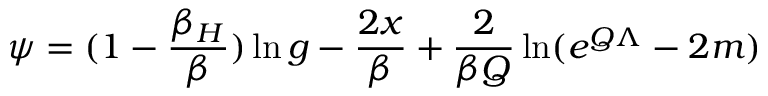Convert formula to latex. <formula><loc_0><loc_0><loc_500><loc_500>\psi = ( 1 - { \frac { \beta _ { H } } { \beta } } ) \ln g - { \frac { 2 x } { \beta } } + { \frac { 2 } { \beta Q } } \ln ( e ^ { Q \Lambda } - 2 m )</formula> 